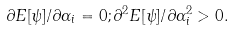<formula> <loc_0><loc_0><loc_500><loc_500>\partial { E } [ \psi ] / \partial \alpha _ { i } = 0 ; \partial ^ { 2 } E [ \psi ] / \partial \alpha _ { i } ^ { 2 } > 0 .</formula> 